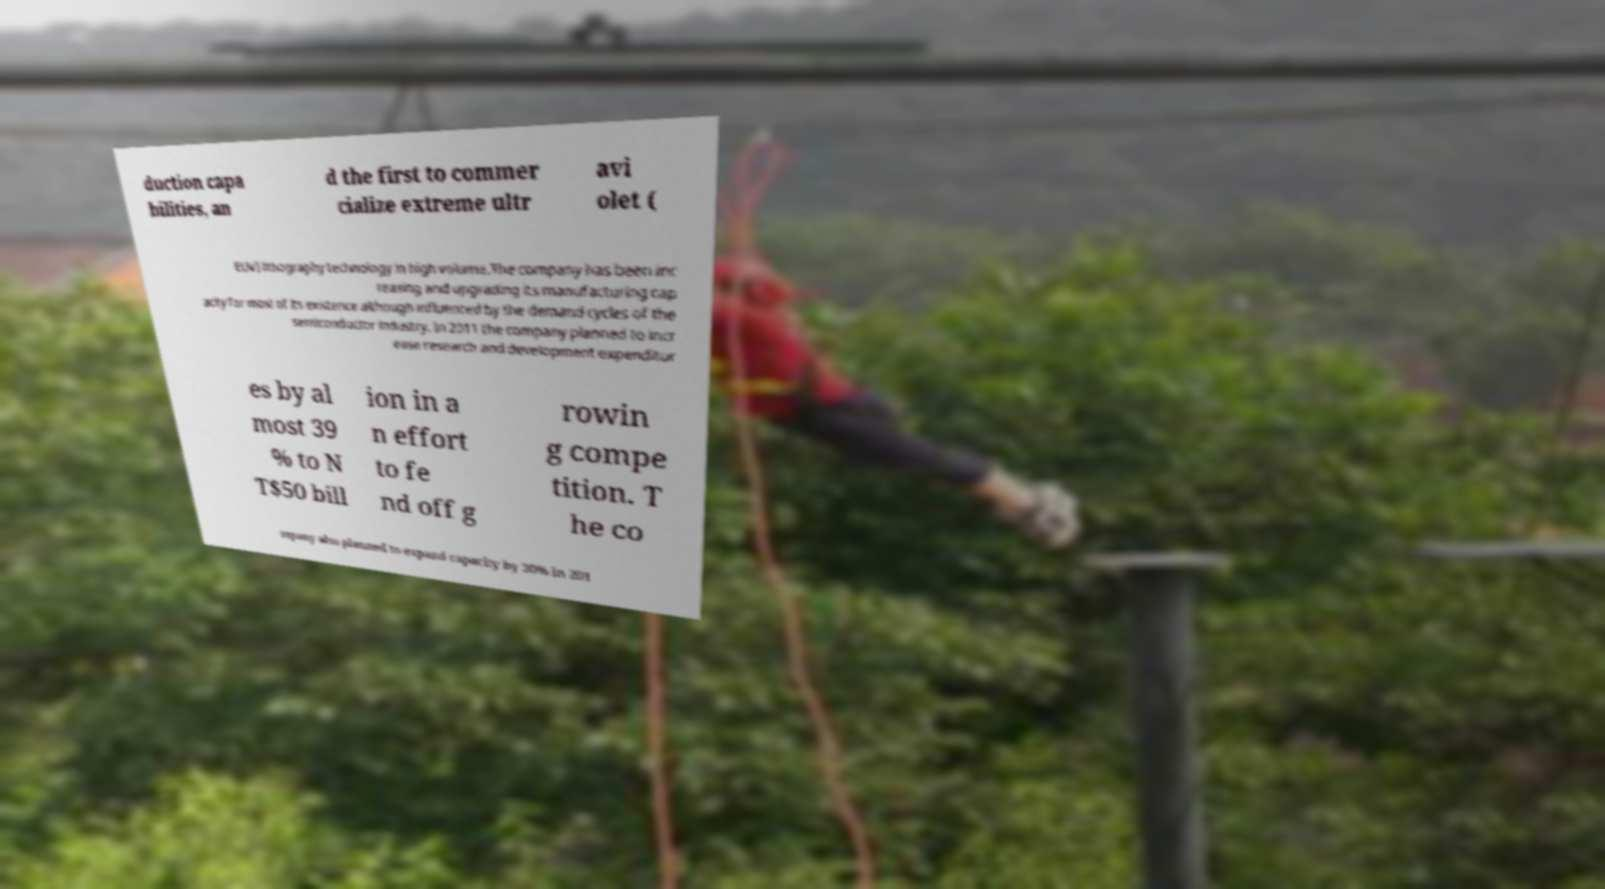Could you assist in decoding the text presented in this image and type it out clearly? duction capa bilities, an d the first to commer cialize extreme ultr avi olet ( EUV) lithography technology in high volume.The company has been inc reasing and upgrading its manufacturing cap acity for most of its existence although influenced by the demand cycles of the semiconductor industry. In 2011 the company planned to incr ease research and development expenditur es by al most 39 % to N T$50 bill ion in a n effort to fe nd off g rowin g compe tition. T he co mpany also planned to expand capacity by 30% in 201 